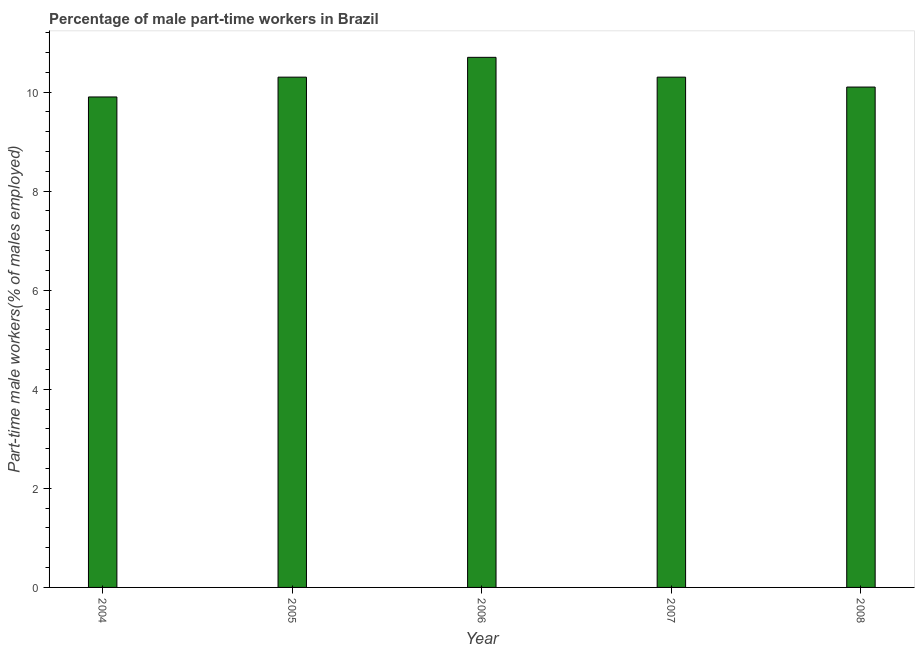What is the title of the graph?
Offer a very short reply. Percentage of male part-time workers in Brazil. What is the label or title of the X-axis?
Provide a short and direct response. Year. What is the label or title of the Y-axis?
Your response must be concise. Part-time male workers(% of males employed). What is the percentage of part-time male workers in 2007?
Provide a succinct answer. 10.3. Across all years, what is the maximum percentage of part-time male workers?
Offer a terse response. 10.7. Across all years, what is the minimum percentage of part-time male workers?
Provide a short and direct response. 9.9. In which year was the percentage of part-time male workers maximum?
Give a very brief answer. 2006. In which year was the percentage of part-time male workers minimum?
Offer a terse response. 2004. What is the sum of the percentage of part-time male workers?
Ensure brevity in your answer.  51.3. What is the average percentage of part-time male workers per year?
Your answer should be compact. 10.26. What is the median percentage of part-time male workers?
Provide a short and direct response. 10.3. In how many years, is the percentage of part-time male workers greater than 9.6 %?
Provide a short and direct response. 5. Is the difference between the percentage of part-time male workers in 2005 and 2008 greater than the difference between any two years?
Give a very brief answer. No. How many bars are there?
Your response must be concise. 5. Are all the bars in the graph horizontal?
Keep it short and to the point. No. How many years are there in the graph?
Offer a terse response. 5. Are the values on the major ticks of Y-axis written in scientific E-notation?
Provide a short and direct response. No. What is the Part-time male workers(% of males employed) of 2004?
Your response must be concise. 9.9. What is the Part-time male workers(% of males employed) in 2005?
Offer a very short reply. 10.3. What is the Part-time male workers(% of males employed) in 2006?
Your response must be concise. 10.7. What is the Part-time male workers(% of males employed) of 2007?
Give a very brief answer. 10.3. What is the Part-time male workers(% of males employed) of 2008?
Offer a terse response. 10.1. What is the difference between the Part-time male workers(% of males employed) in 2004 and 2006?
Your answer should be compact. -0.8. What is the difference between the Part-time male workers(% of males employed) in 2004 and 2008?
Ensure brevity in your answer.  -0.2. What is the difference between the Part-time male workers(% of males employed) in 2005 and 2007?
Offer a very short reply. 0. What is the difference between the Part-time male workers(% of males employed) in 2006 and 2007?
Keep it short and to the point. 0.4. What is the difference between the Part-time male workers(% of males employed) in 2007 and 2008?
Your response must be concise. 0.2. What is the ratio of the Part-time male workers(% of males employed) in 2004 to that in 2005?
Provide a succinct answer. 0.96. What is the ratio of the Part-time male workers(% of males employed) in 2004 to that in 2006?
Ensure brevity in your answer.  0.93. What is the ratio of the Part-time male workers(% of males employed) in 2005 to that in 2006?
Your answer should be compact. 0.96. What is the ratio of the Part-time male workers(% of males employed) in 2006 to that in 2007?
Offer a very short reply. 1.04. What is the ratio of the Part-time male workers(% of males employed) in 2006 to that in 2008?
Keep it short and to the point. 1.06. What is the ratio of the Part-time male workers(% of males employed) in 2007 to that in 2008?
Offer a very short reply. 1.02. 